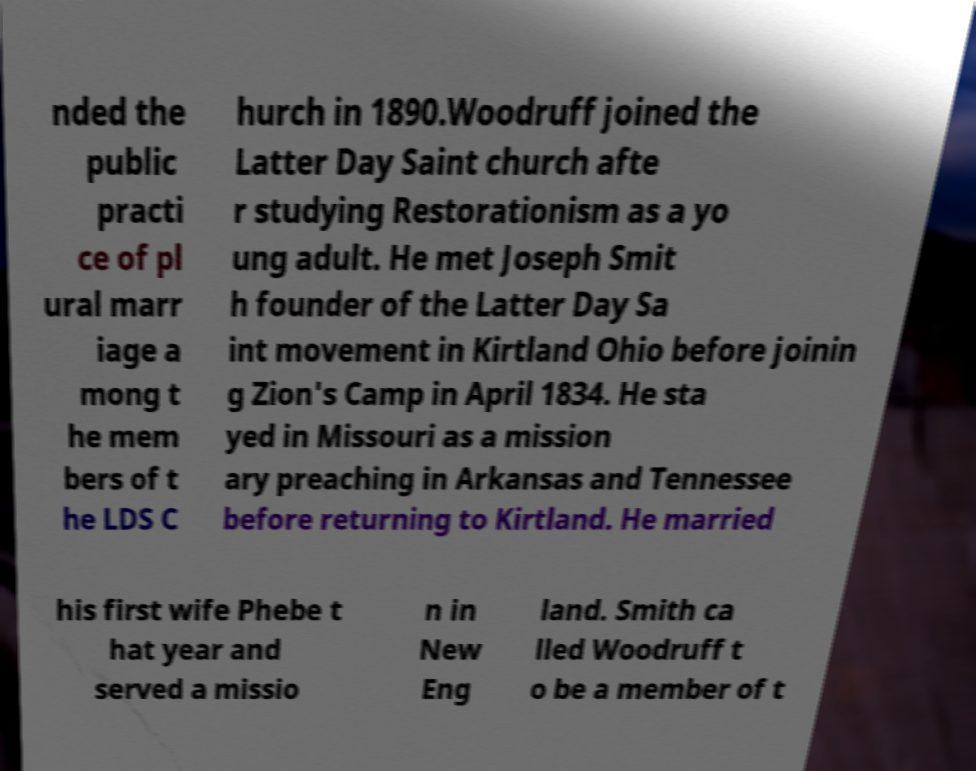What messages or text are displayed in this image? I need them in a readable, typed format. nded the public practi ce of pl ural marr iage a mong t he mem bers of t he LDS C hurch in 1890.Woodruff joined the Latter Day Saint church afte r studying Restorationism as a yo ung adult. He met Joseph Smit h founder of the Latter Day Sa int movement in Kirtland Ohio before joinin g Zion's Camp in April 1834. He sta yed in Missouri as a mission ary preaching in Arkansas and Tennessee before returning to Kirtland. He married his first wife Phebe t hat year and served a missio n in New Eng land. Smith ca lled Woodruff t o be a member of t 